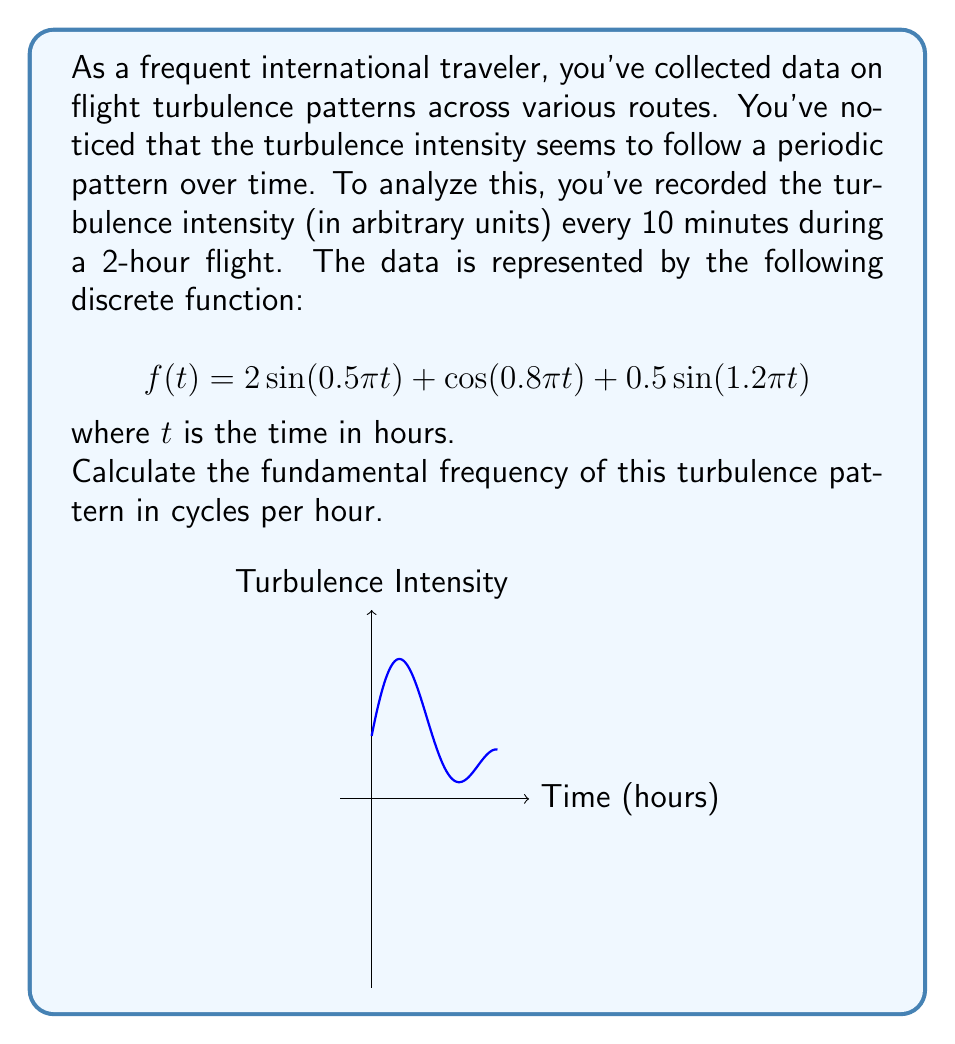Solve this math problem. To find the fundamental frequency of the turbulence pattern, we need to analyze the frequency components in the given function. Let's break this down step-by-step:

1) The given function is a sum of three sinusoidal components:
   $$f(t) = 2\sin(0.5\pi t) + \cos(0.8\pi t) + 0.5\sin(1.2\pi t)$$

2) For each component, we can identify its angular frequency $\omega$:
   - Component 1: $\omega_1 = 0.5\pi$
   - Component 2: $\omega_2 = 0.8\pi$
   - Component 3: $\omega_3 = 1.2\pi$

3) To convert angular frequency to frequency in cycles per hour, we use the formula:
   $$f = \frac{\omega}{2\pi}$$

4) Calculating the frequencies:
   - $f_1 = \frac{0.5\pi}{2\pi} = 0.25$ cycles/hour
   - $f_2 = \frac{0.8\pi}{2\pi} = 0.4$ cycles/hour
   - $f_3 = \frac{1.2\pi}{2\pi} = 0.6$ cycles/hour

5) The fundamental frequency is the greatest common divisor (GCD) of all frequency components. To find this, we can express these frequencies as ratios of integers:
   - $f_1 = 25/100 = 1/4$
   - $f_2 = 40/100 = 2/5$
   - $f_3 = 60/100 = 3/5$

6) The GCD of the numerators is 1, and the least common multiple of the denominators is 20. Therefore, the fundamental frequency is:
   $$f_0 = \frac{1}{20} = 0.05$$ cycles per hour

This means the basic repeating pattern of the turbulence occurs every 20 hours.
Answer: 0.05 cycles/hour 